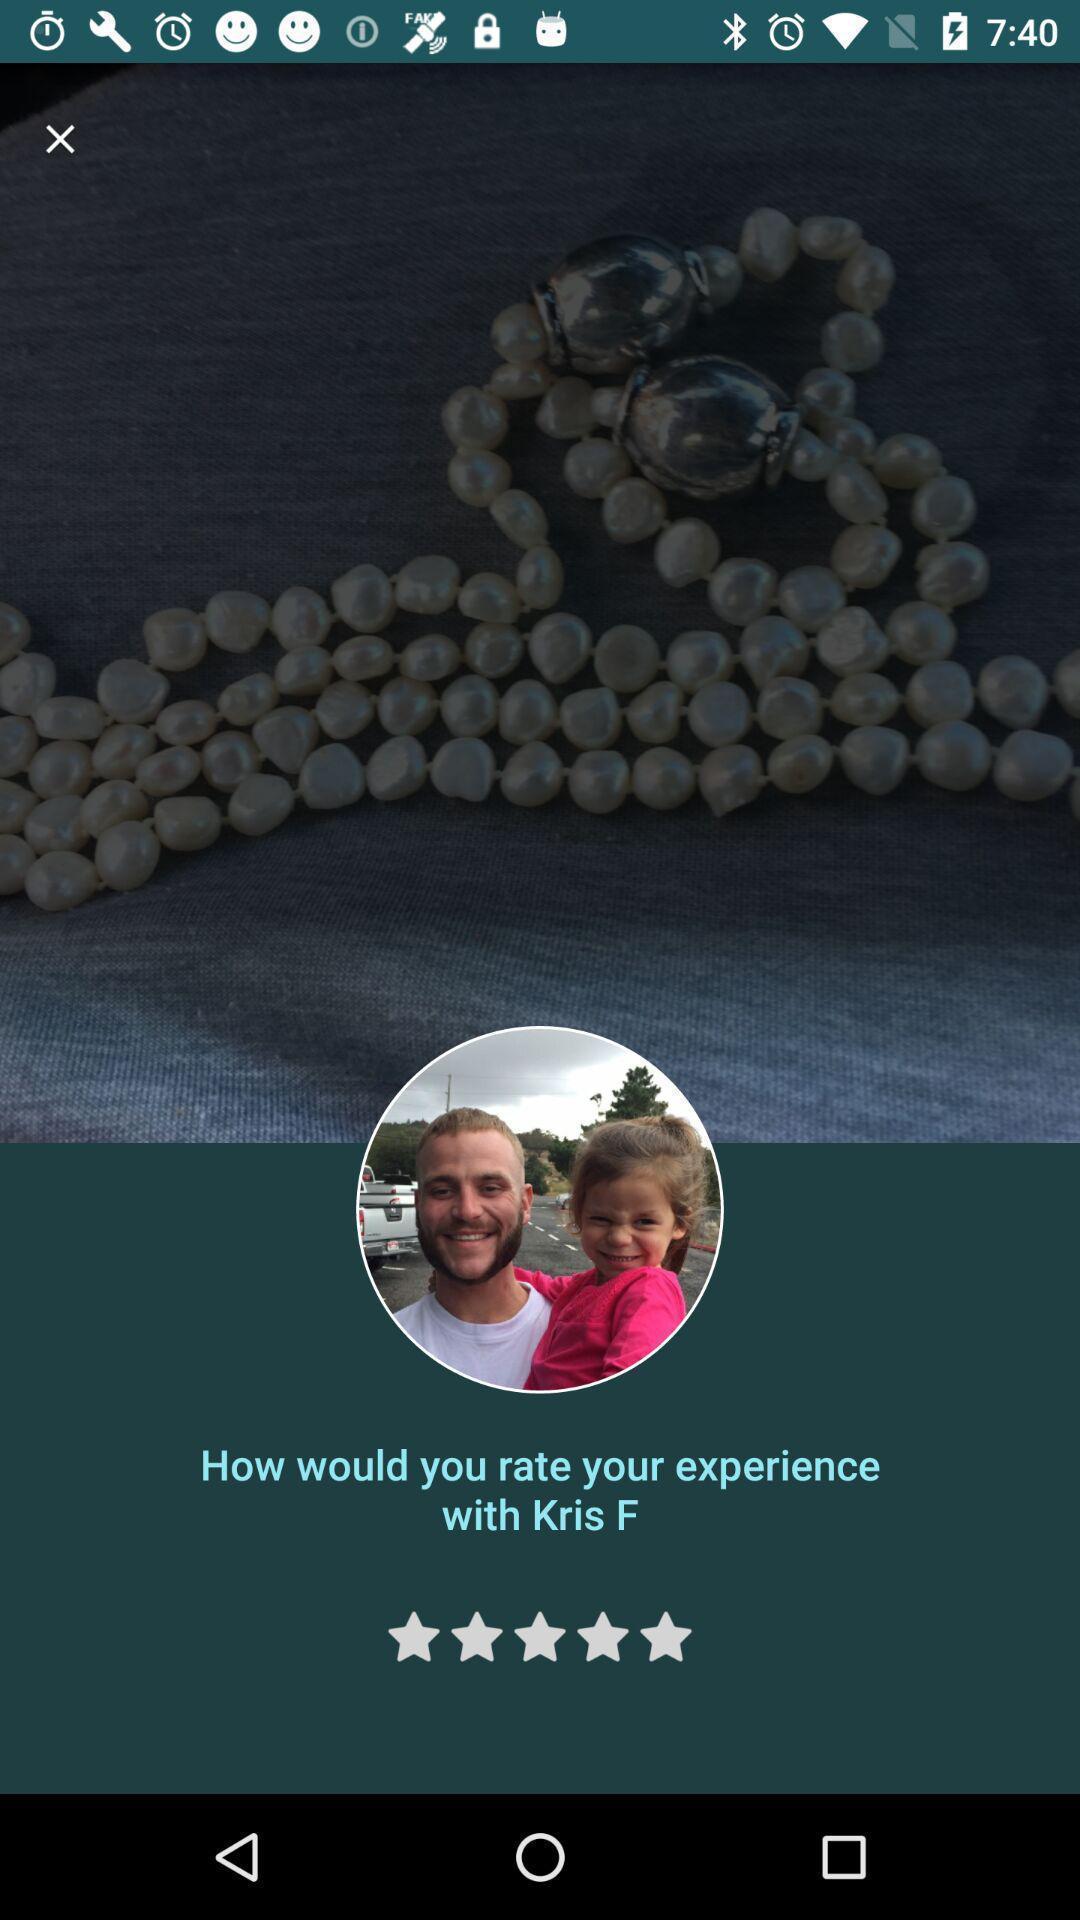Give me a narrative description of this picture. Screen displaying page to rate your experience. 